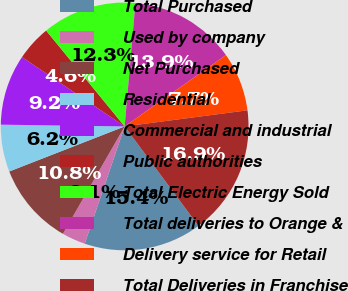Convert chart. <chart><loc_0><loc_0><loc_500><loc_500><pie_chart><fcel>Total Purchased<fcel>Used by company<fcel>Net Purchased<fcel>Residential<fcel>Commercial and industrial<fcel>Public authorities<fcel>Total Electric Energy Sold<fcel>Total deliveries to Orange &<fcel>Delivery service for Retail<fcel>Total Deliveries in Franchise<nl><fcel>15.38%<fcel>3.08%<fcel>10.77%<fcel>6.15%<fcel>9.23%<fcel>4.62%<fcel>12.31%<fcel>13.85%<fcel>7.69%<fcel>16.92%<nl></chart> 